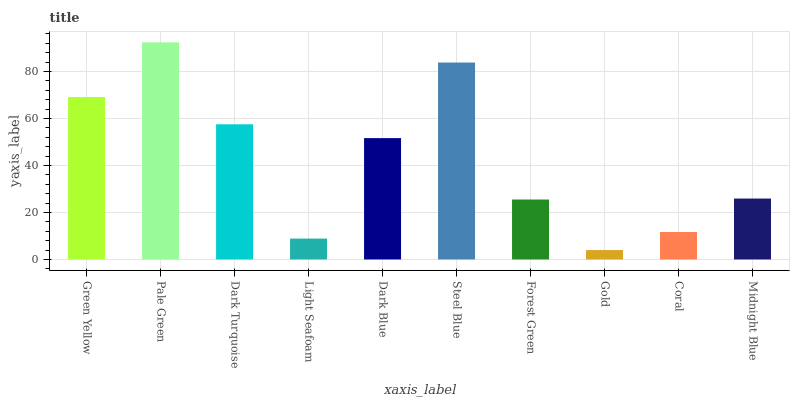Is Gold the minimum?
Answer yes or no. Yes. Is Pale Green the maximum?
Answer yes or no. Yes. Is Dark Turquoise the minimum?
Answer yes or no. No. Is Dark Turquoise the maximum?
Answer yes or no. No. Is Pale Green greater than Dark Turquoise?
Answer yes or no. Yes. Is Dark Turquoise less than Pale Green?
Answer yes or no. Yes. Is Dark Turquoise greater than Pale Green?
Answer yes or no. No. Is Pale Green less than Dark Turquoise?
Answer yes or no. No. Is Dark Blue the high median?
Answer yes or no. Yes. Is Midnight Blue the low median?
Answer yes or no. Yes. Is Steel Blue the high median?
Answer yes or no. No. Is Dark Turquoise the low median?
Answer yes or no. No. 